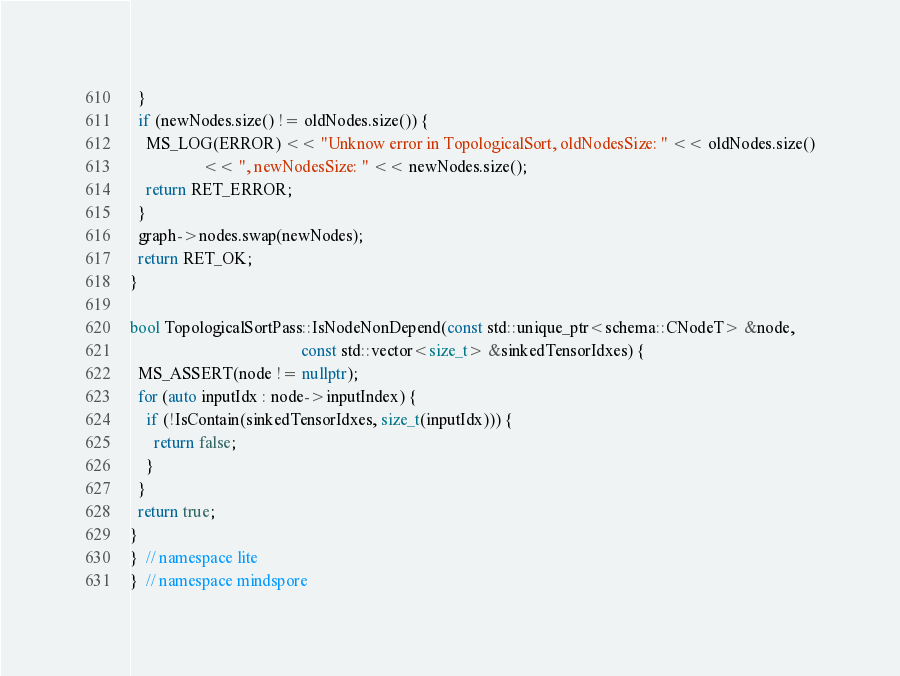<code> <loc_0><loc_0><loc_500><loc_500><_C++_>  }
  if (newNodes.size() != oldNodes.size()) {
    MS_LOG(ERROR) << "Unknow error in TopologicalSort, oldNodesSize: " << oldNodes.size()
                  << ", newNodesSize: " << newNodes.size();
    return RET_ERROR;
  }
  graph->nodes.swap(newNodes);
  return RET_OK;
}

bool TopologicalSortPass::IsNodeNonDepend(const std::unique_ptr<schema::CNodeT> &node,
                                          const std::vector<size_t> &sinkedTensorIdxes) {
  MS_ASSERT(node != nullptr);
  for (auto inputIdx : node->inputIndex) {
    if (!IsContain(sinkedTensorIdxes, size_t(inputIdx))) {
      return false;
    }
  }
  return true;
}
}  // namespace lite
}  // namespace mindspore
</code> 